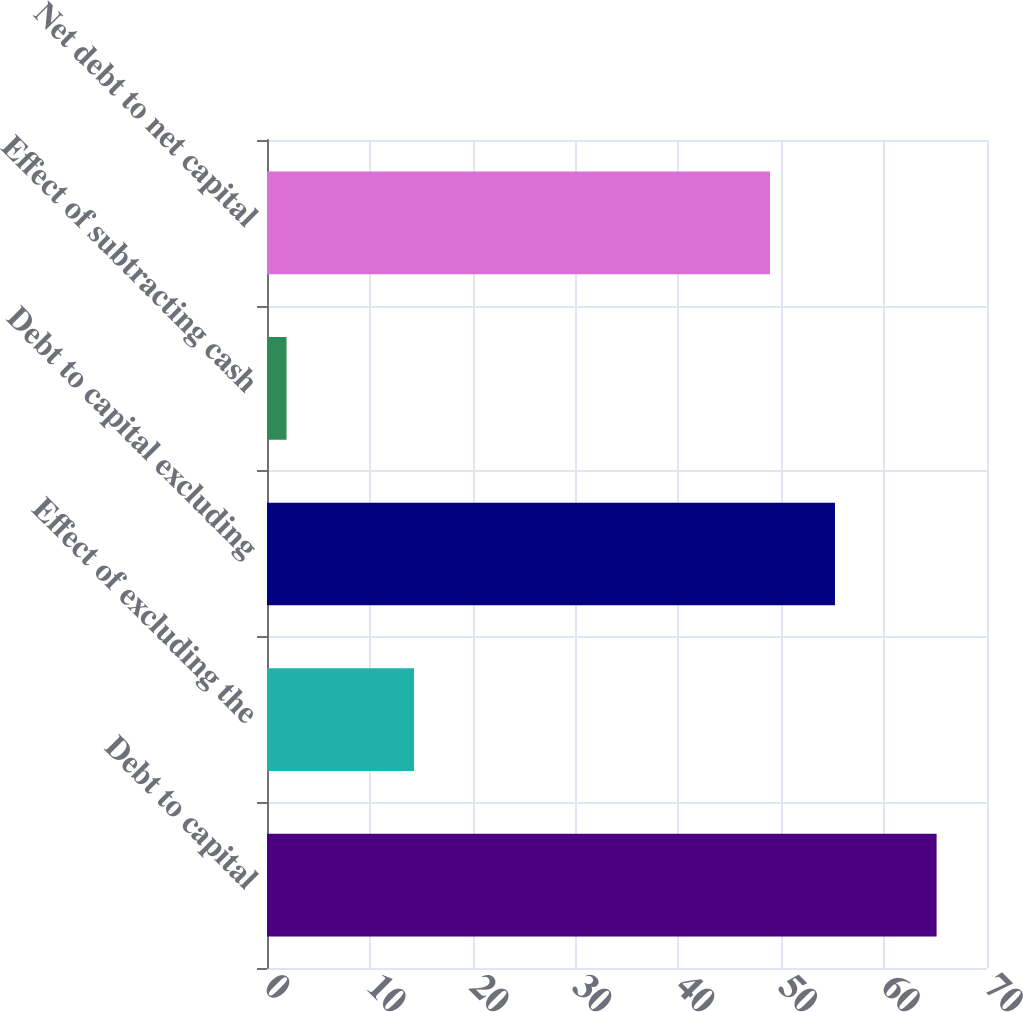Convert chart to OTSL. <chart><loc_0><loc_0><loc_500><loc_500><bar_chart><fcel>Debt to capital<fcel>Effect of excluding the<fcel>Debt to capital excluding<fcel>Effect of subtracting cash<fcel>Net debt to net capital<nl><fcel>65.1<fcel>14.3<fcel>55.22<fcel>1.9<fcel>48.9<nl></chart> 